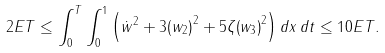<formula> <loc_0><loc_0><loc_500><loc_500>2 E T \leq \int _ { 0 } ^ { T } { \int _ { 0 } ^ { 1 } { \left ( { { { \dot { w } } } ^ { 2 } } + 3 { { \left ( { { w } _ { 2 } } \right ) } ^ { 2 } } + 5 \zeta { { \left ( { { w } _ { 3 } } \right ) } ^ { 2 } } \right ) d x \, d t } } \leq 1 0 E T .</formula> 